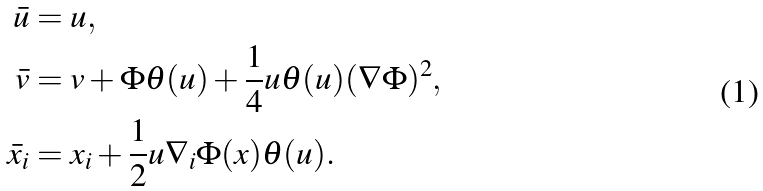Convert formula to latex. <formula><loc_0><loc_0><loc_500><loc_500>\bar { u } & = u , \\ \bar { v } & = v + \Phi \theta ( u ) + \frac { 1 } { 4 } u \theta ( u ) ( \nabla \Phi ) ^ { 2 } , \\ \bar { x } _ { i } & = x _ { i } + \frac { 1 } { 2 } u \nabla _ { i } \Phi ( x ) \theta ( u ) .</formula> 